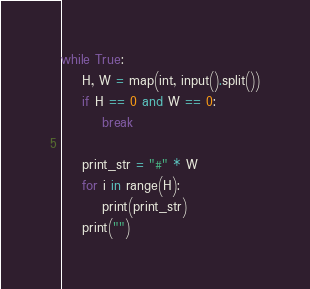Convert code to text. <code><loc_0><loc_0><loc_500><loc_500><_Python_>while True:
    H, W = map(int, input().split())
    if H == 0 and W == 0:
        break
    
    print_str = "#" * W
    for i in range(H):
        print(print_str)
    print("")
</code> 